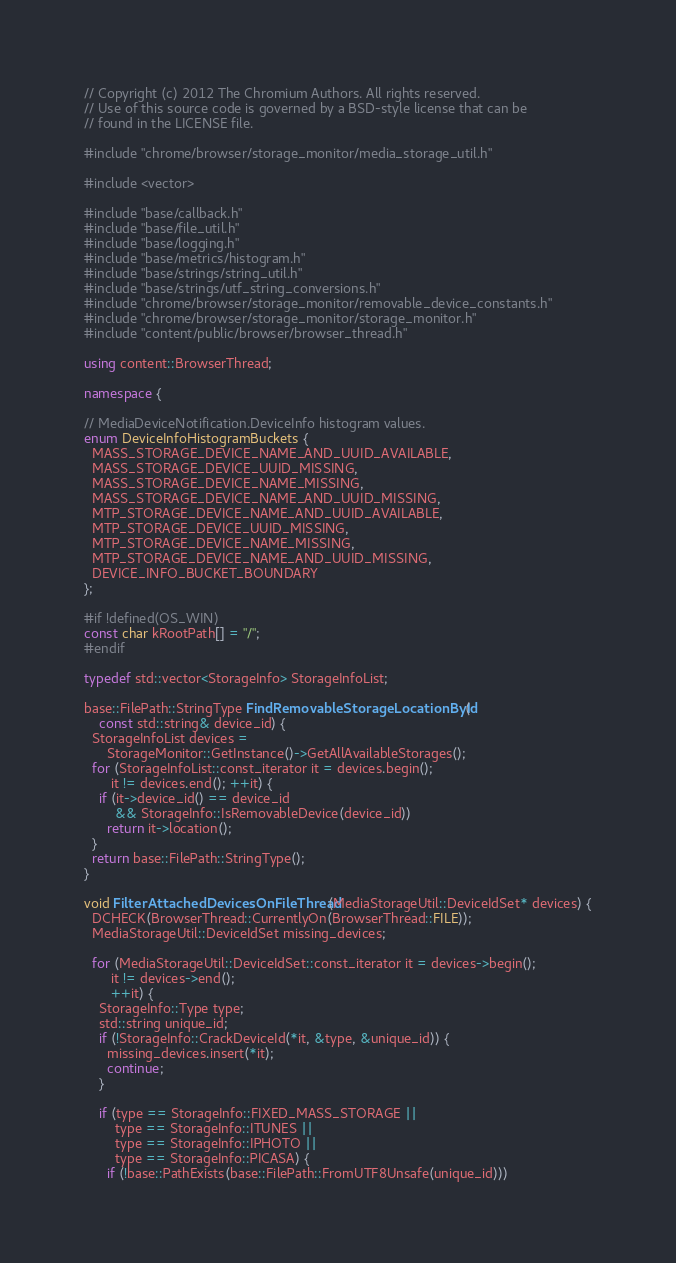<code> <loc_0><loc_0><loc_500><loc_500><_C++_>// Copyright (c) 2012 The Chromium Authors. All rights reserved.
// Use of this source code is governed by a BSD-style license that can be
// found in the LICENSE file.

#include "chrome/browser/storage_monitor/media_storage_util.h"

#include <vector>

#include "base/callback.h"
#include "base/file_util.h"
#include "base/logging.h"
#include "base/metrics/histogram.h"
#include "base/strings/string_util.h"
#include "base/strings/utf_string_conversions.h"
#include "chrome/browser/storage_monitor/removable_device_constants.h"
#include "chrome/browser/storage_monitor/storage_monitor.h"
#include "content/public/browser/browser_thread.h"

using content::BrowserThread;

namespace {

// MediaDeviceNotification.DeviceInfo histogram values.
enum DeviceInfoHistogramBuckets {
  MASS_STORAGE_DEVICE_NAME_AND_UUID_AVAILABLE,
  MASS_STORAGE_DEVICE_UUID_MISSING,
  MASS_STORAGE_DEVICE_NAME_MISSING,
  MASS_STORAGE_DEVICE_NAME_AND_UUID_MISSING,
  MTP_STORAGE_DEVICE_NAME_AND_UUID_AVAILABLE,
  MTP_STORAGE_DEVICE_UUID_MISSING,
  MTP_STORAGE_DEVICE_NAME_MISSING,
  MTP_STORAGE_DEVICE_NAME_AND_UUID_MISSING,
  DEVICE_INFO_BUCKET_BOUNDARY
};

#if !defined(OS_WIN)
const char kRootPath[] = "/";
#endif

typedef std::vector<StorageInfo> StorageInfoList;

base::FilePath::StringType FindRemovableStorageLocationById(
    const std::string& device_id) {
  StorageInfoList devices =
      StorageMonitor::GetInstance()->GetAllAvailableStorages();
  for (StorageInfoList::const_iterator it = devices.begin();
       it != devices.end(); ++it) {
    if (it->device_id() == device_id
        && StorageInfo::IsRemovableDevice(device_id))
      return it->location();
  }
  return base::FilePath::StringType();
}

void FilterAttachedDevicesOnFileThread(MediaStorageUtil::DeviceIdSet* devices) {
  DCHECK(BrowserThread::CurrentlyOn(BrowserThread::FILE));
  MediaStorageUtil::DeviceIdSet missing_devices;

  for (MediaStorageUtil::DeviceIdSet::const_iterator it = devices->begin();
       it != devices->end();
       ++it) {
    StorageInfo::Type type;
    std::string unique_id;
    if (!StorageInfo::CrackDeviceId(*it, &type, &unique_id)) {
      missing_devices.insert(*it);
      continue;
    }

    if (type == StorageInfo::FIXED_MASS_STORAGE ||
        type == StorageInfo::ITUNES ||
        type == StorageInfo::IPHOTO ||
        type == StorageInfo::PICASA) {
      if (!base::PathExists(base::FilePath::FromUTF8Unsafe(unique_id)))</code> 